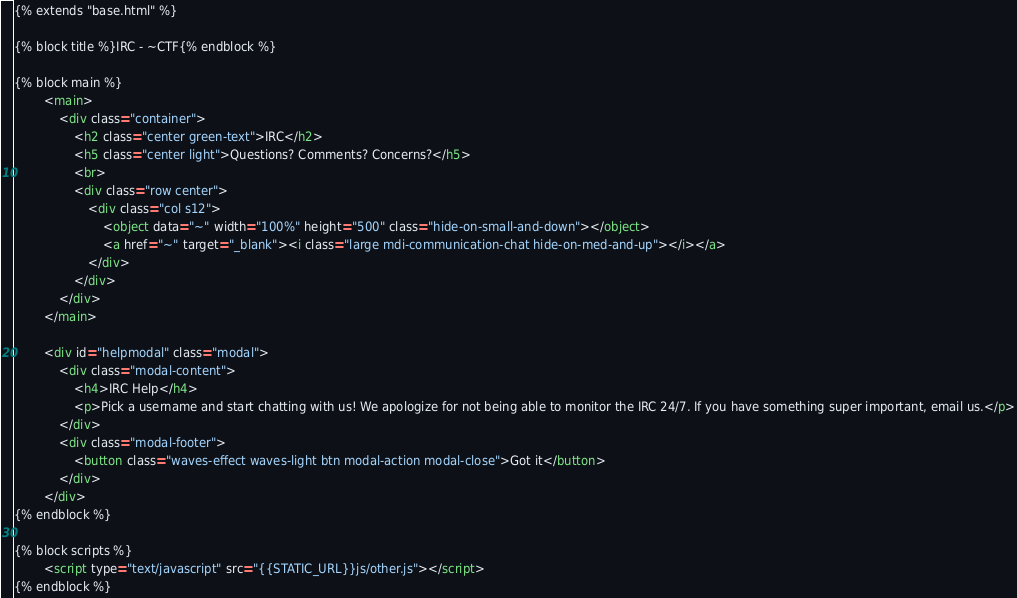Convert code to text. <code><loc_0><loc_0><loc_500><loc_500><_HTML_>{% extends "base.html" %}

{% block title %}IRC - ~CTF{% endblock %}

{% block main %}
		<main>
			<div class="container">
				<h2 class="center green-text">IRC</h2>
				<h5 class="center light">Questions? Comments? Concerns?</h5>
				<br>
				<div class="row center">
					<div class="col s12">
						<object data="~" width="100%" height="500" class="hide-on-small-and-down"></object>
						<a href="~" target="_blank"><i class="large mdi-communication-chat hide-on-med-and-up"></i></a>
					</div>
				</div>
			</div>
		</main>
		
		<div id="helpmodal" class="modal">
			<div class="modal-content">
				<h4>IRC Help</h4>
				<p>Pick a username and start chatting with us! We apologize for not being able to monitor the IRC 24/7. If you have something super important, email us.</p>
			</div>
			<div class="modal-footer">
				<button class="waves-effect waves-light btn modal-action modal-close">Got it</button>
			</div>
		</div>
{% endblock %}

{% block scripts %}
		<script type="text/javascript" src="{{STATIC_URL}}js/other.js"></script>
{% endblock %}</code> 